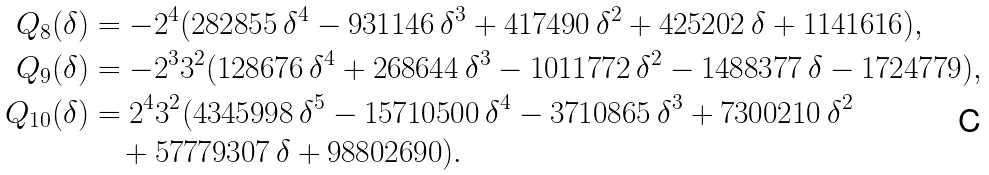Convert formula to latex. <formula><loc_0><loc_0><loc_500><loc_500>Q _ { 8 } ( \delta ) & = - 2 ^ { 4 } ( 2 8 2 8 5 5 \, \delta ^ { 4 } - 9 3 1 1 4 6 \, \delta ^ { 3 } + 4 1 7 4 9 0 \, \delta ^ { 2 } + 4 2 5 2 0 2 \, \delta + 1 1 4 1 6 1 6 ) , \\ Q _ { 9 } ( \delta ) & = - 2 ^ { 3 } 3 ^ { 2 } ( 1 2 8 6 7 6 \, \delta ^ { 4 } + 2 6 8 6 4 4 \, \delta ^ { 3 } - 1 0 1 1 7 7 2 \, \delta ^ { 2 } - 1 4 8 8 3 7 7 \, \delta - 1 7 2 4 7 7 9 ) , \\ Q _ { 1 0 } ( \delta ) & = 2 ^ { 4 } 3 ^ { 2 } ( 4 3 4 5 9 9 8 \, \delta ^ { 5 } - 1 5 7 1 0 5 0 0 \, \delta ^ { 4 } - 3 7 1 0 8 6 5 \, \delta ^ { 3 } + 7 3 0 0 2 1 0 \, \delta ^ { 2 } \\ & \quad + 5 7 7 7 9 3 0 7 \, \delta + 9 8 8 0 2 6 9 0 ) .</formula> 